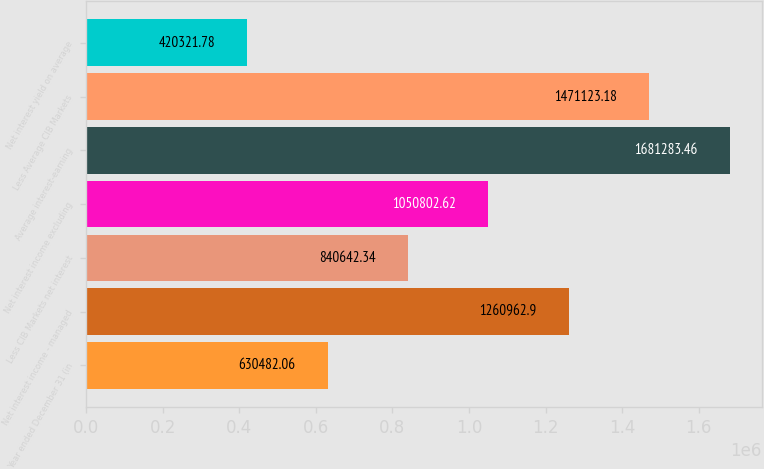Convert chart to OTSL. <chart><loc_0><loc_0><loc_500><loc_500><bar_chart><fcel>Year ended December 31 (in<fcel>Net interest income - managed<fcel>Less CIB Markets net interest<fcel>Net interest income excluding<fcel>Average interest-earning<fcel>Less Average CIB Markets<fcel>Net interest yield on average<nl><fcel>630482<fcel>1.26096e+06<fcel>840642<fcel>1.0508e+06<fcel>1.68128e+06<fcel>1.47112e+06<fcel>420322<nl></chart> 